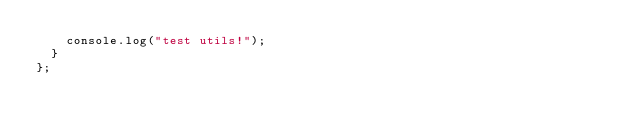Convert code to text. <code><loc_0><loc_0><loc_500><loc_500><_TypeScript_>    console.log("test utils!");
  }
};
</code> 